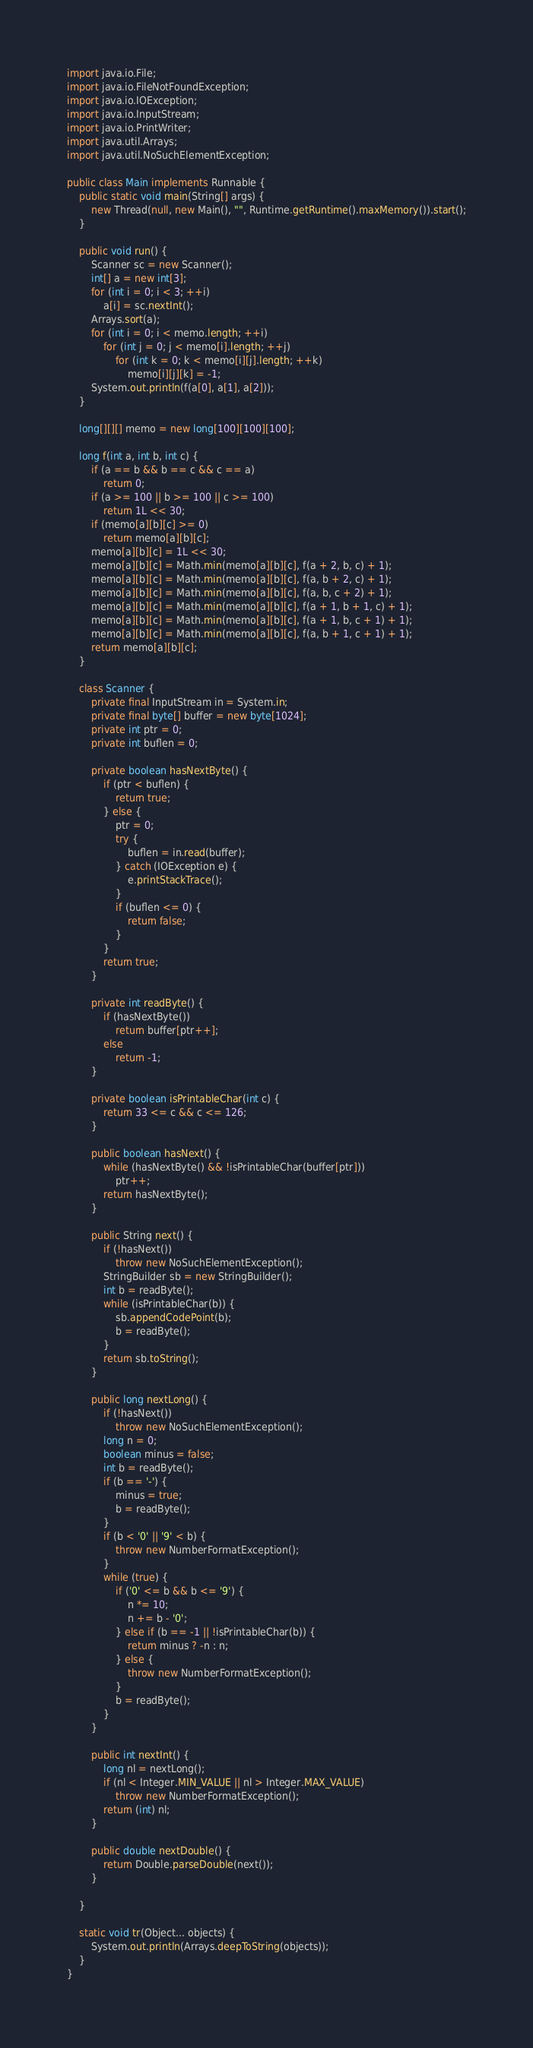<code> <loc_0><loc_0><loc_500><loc_500><_Java_>import java.io.File;
import java.io.FileNotFoundException;
import java.io.IOException;
import java.io.InputStream;
import java.io.PrintWriter;
import java.util.Arrays;
import java.util.NoSuchElementException;

public class Main implements Runnable {
	public static void main(String[] args) {
		new Thread(null, new Main(), "", Runtime.getRuntime().maxMemory()).start();
	}

	public void run() {
		Scanner sc = new Scanner();
		int[] a = new int[3];
		for (int i = 0; i < 3; ++i)
			a[i] = sc.nextInt();
		Arrays.sort(a);
		for (int i = 0; i < memo.length; ++i)
			for (int j = 0; j < memo[i].length; ++j)
				for (int k = 0; k < memo[i][j].length; ++k)
					memo[i][j][k] = -1;
		System.out.println(f(a[0], a[1], a[2]));
	}

	long[][][] memo = new long[100][100][100];

	long f(int a, int b, int c) {
		if (a == b && b == c && c == a)
			return 0;
		if (a >= 100 || b >= 100 || c >= 100)
			return 1L << 30;
		if (memo[a][b][c] >= 0)
			return memo[a][b][c];
		memo[a][b][c] = 1L << 30;
		memo[a][b][c] = Math.min(memo[a][b][c], f(a + 2, b, c) + 1);
		memo[a][b][c] = Math.min(memo[a][b][c], f(a, b + 2, c) + 1);
		memo[a][b][c] = Math.min(memo[a][b][c], f(a, b, c + 2) + 1);
		memo[a][b][c] = Math.min(memo[a][b][c], f(a + 1, b + 1, c) + 1);
		memo[a][b][c] = Math.min(memo[a][b][c], f(a + 1, b, c + 1) + 1);
		memo[a][b][c] = Math.min(memo[a][b][c], f(a, b + 1, c + 1) + 1);
		return memo[a][b][c];
	}

	class Scanner {
		private final InputStream in = System.in;
		private final byte[] buffer = new byte[1024];
		private int ptr = 0;
		private int buflen = 0;

		private boolean hasNextByte() {
			if (ptr < buflen) {
				return true;
			} else {
				ptr = 0;
				try {
					buflen = in.read(buffer);
				} catch (IOException e) {
					e.printStackTrace();
				}
				if (buflen <= 0) {
					return false;
				}
			}
			return true;
		}

		private int readByte() {
			if (hasNextByte())
				return buffer[ptr++];
			else
				return -1;
		}

		private boolean isPrintableChar(int c) {
			return 33 <= c && c <= 126;
		}

		public boolean hasNext() {
			while (hasNextByte() && !isPrintableChar(buffer[ptr]))
				ptr++;
			return hasNextByte();
		}

		public String next() {
			if (!hasNext())
				throw new NoSuchElementException();
			StringBuilder sb = new StringBuilder();
			int b = readByte();
			while (isPrintableChar(b)) {
				sb.appendCodePoint(b);
				b = readByte();
			}
			return sb.toString();
		}

		public long nextLong() {
			if (!hasNext())
				throw new NoSuchElementException();
			long n = 0;
			boolean minus = false;
			int b = readByte();
			if (b == '-') {
				minus = true;
				b = readByte();
			}
			if (b < '0' || '9' < b) {
				throw new NumberFormatException();
			}
			while (true) {
				if ('0' <= b && b <= '9') {
					n *= 10;
					n += b - '0';
				} else if (b == -1 || !isPrintableChar(b)) {
					return minus ? -n : n;
				} else {
					throw new NumberFormatException();
				}
				b = readByte();
			}
		}

		public int nextInt() {
			long nl = nextLong();
			if (nl < Integer.MIN_VALUE || nl > Integer.MAX_VALUE)
				throw new NumberFormatException();
			return (int) nl;
		}

		public double nextDouble() {
			return Double.parseDouble(next());
		}

	}

	static void tr(Object... objects) {
		System.out.println(Arrays.deepToString(objects));
	}
}
</code> 